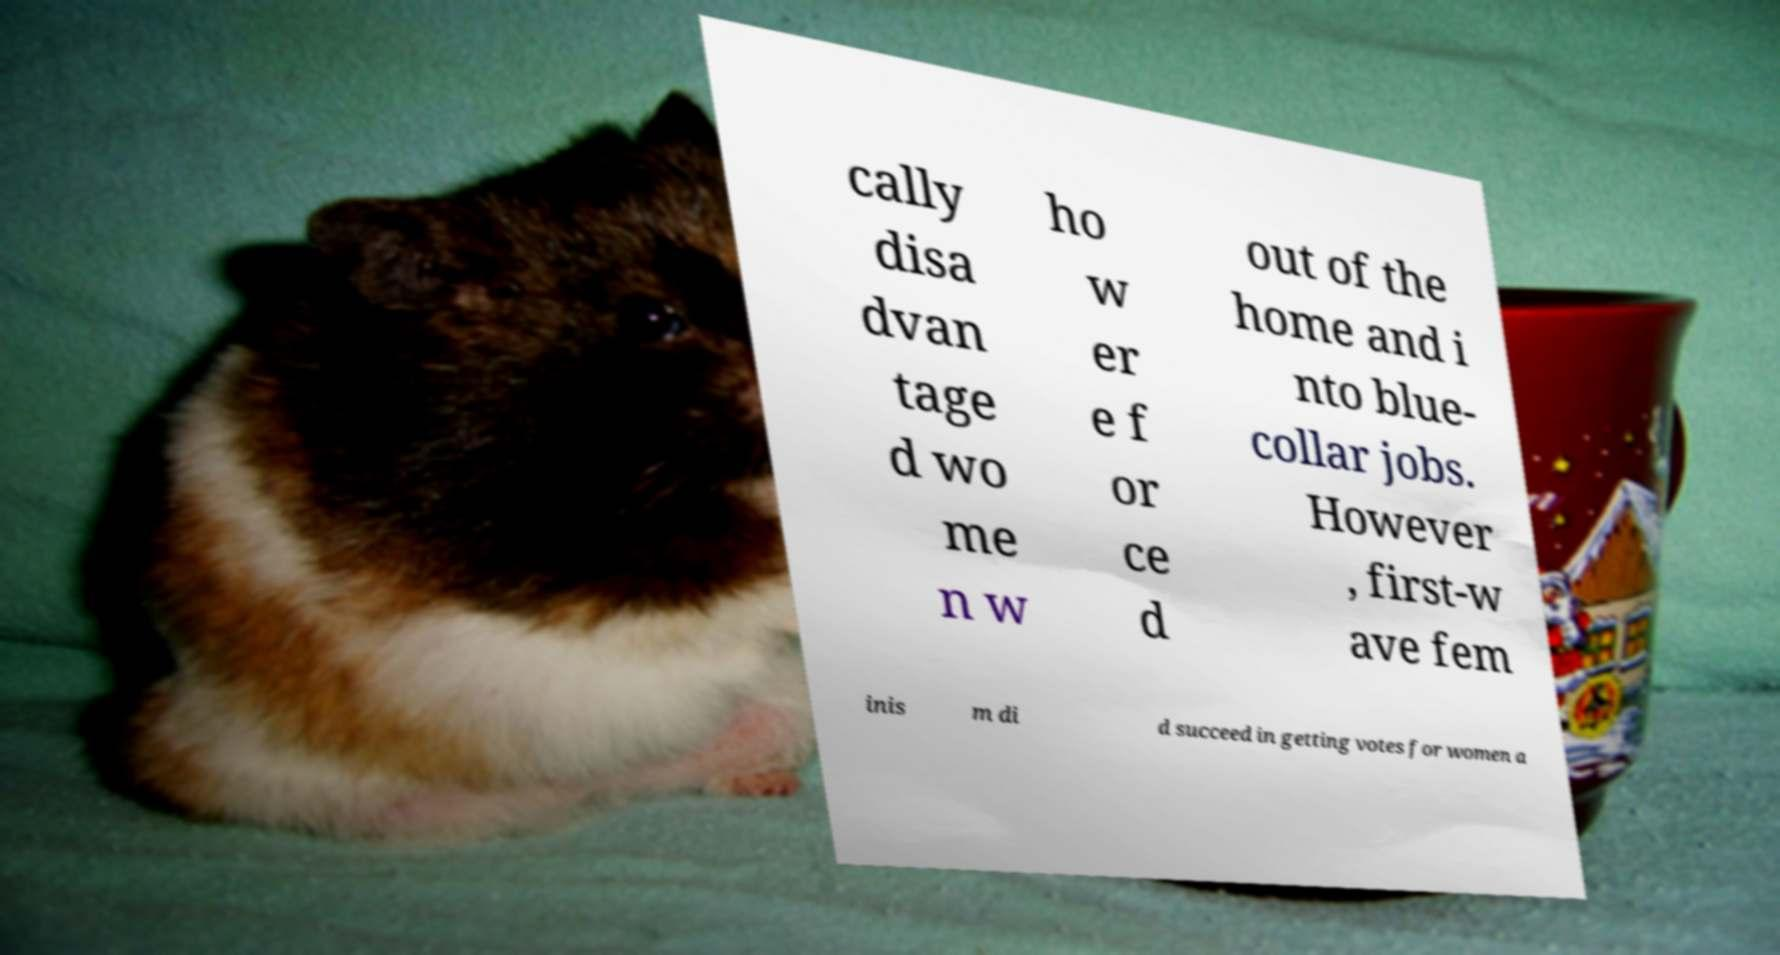What messages or text are displayed in this image? I need them in a readable, typed format. cally disa dvan tage d wo me n w ho w er e f or ce d out of the home and i nto blue- collar jobs. However , first-w ave fem inis m di d succeed in getting votes for women a 